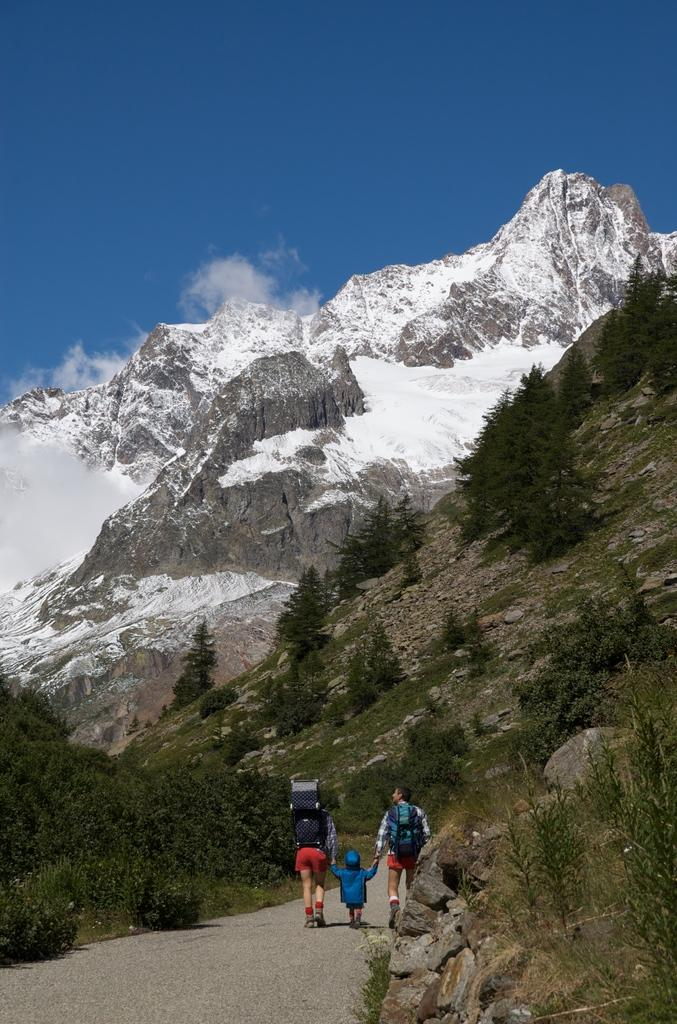What are the people in the image doing? There are people walking on the pathway in the image. What type of vegetation can be seen in the image? There is a group of trees and plants in the image. What type of terrain is visible in the image? There are stones, a mountain, and an ice hill in the image. What is the condition of the sky in the image? The sky is visible in the image and appears cloudy. What type of quiver is being used by the people walking on the pathway? There is no mention of a quiver in the image, as the people are simply walking on the pathway. How does the knee of the mountain affect the ice hill in the image? There is no mention of a knee in the context of the mountain or the ice hill in the image. 